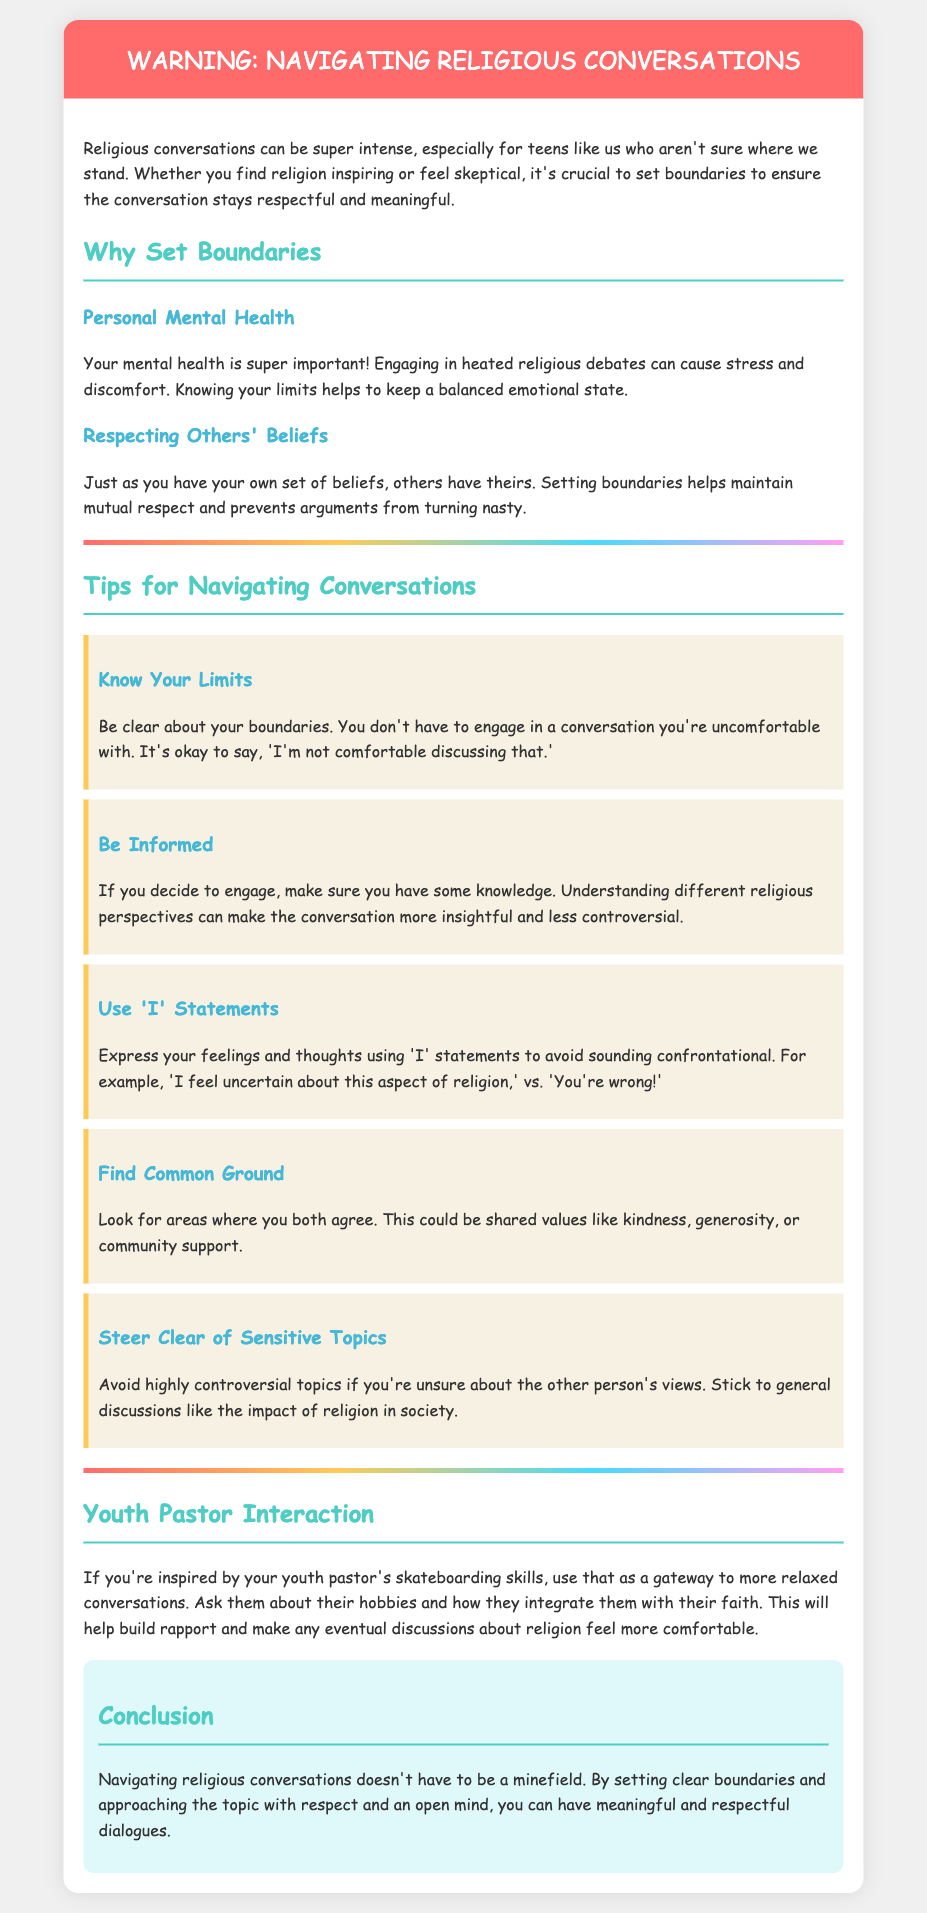What is the title of the document? The title of the document is explicitly stated in the header section as "Warning: Navigating Religious Conversations."
Answer: Warning: Navigating Religious Conversations What is one reason for setting boundaries? The document emphasizes the importance of boundaries for personal mental health, preventing stress and discomfort during debates.
Answer: Personal Mental Health Name one tip for navigating conversations. The document lists several tips; one of them includes being informed about different religious perspectives.
Answer: Be Informed What color is used for the header background? The background color of the header section is described in the document as a shade of red.
Answer: #ff6b6b What should you avoid discussing if unsure? The document advises steering clear of highly controversial topics if you're not aware of the other person's views.
Answer: Sensitive Topics What does the youth pastor's skateboarding skills represent? The document mentions using the inspiration from the youth pastor's skateboarding to facilitate relaxed conversations.
Answer: Gateway to relaxed conversations How many tips are provided for navigating conversations? The document lists five tips under the section "Tips for Navigating Conversations."
Answer: Five What does using 'I' statements help with? According to the document, using 'I' statements helps to avoid sounding confrontational.
Answer: Avoid sounding confrontational What color is the conclusion background? The document describes the background color of the conclusion section as a light blue hue.
Answer: #dff9fb 